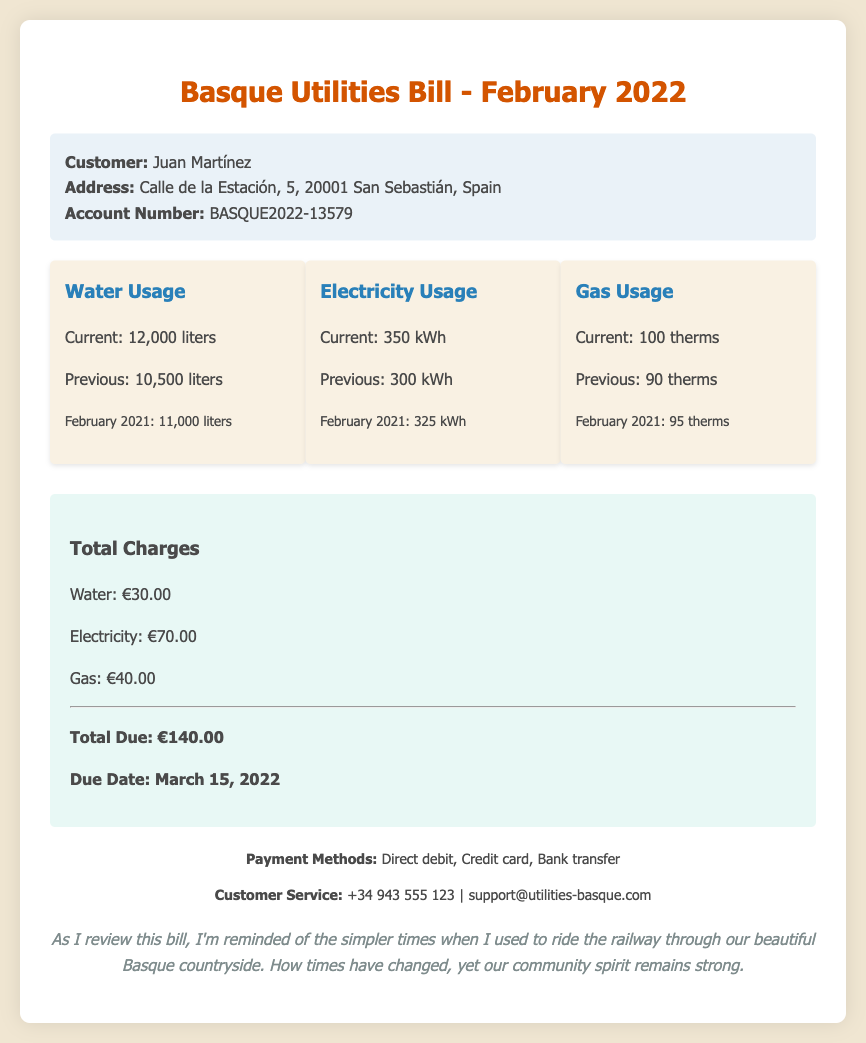What is the account number? The account number is listed under customer info in the document, which is a reference for billing.
Answer: BASQUE2022-13579 What was the water usage in February 2021? The water usage for February 2021 is mentioned as a historical comparison to current usage.
Answer: 11,000 liters How much is the total due? The total due is calculated based on the charges for all utilities listed in the document.
Answer: €140.00 What is the current gas usage? The current gas usage is presented with a clear label in the usage section of the document.
Answer: 100 therms Which utility had the highest charge? By comparing the individual charges listed, it's clear which utility costs the most this month.
Answer: Electricity How many liters of water were used in the previous month? The previous month's water usage is indicated for comparative analysis in the usage section.
Answer: 10,500 liters What is the payment due date? The payment due date is specified in the total charges section of the document, indicating when payment is expected.
Answer: March 15, 2022 What is the electricity usage in kilowatt-hours? The usage for electricity is specified in the usage section of the document, showing the units of measurement clearly.
Answer: 350 kWh 